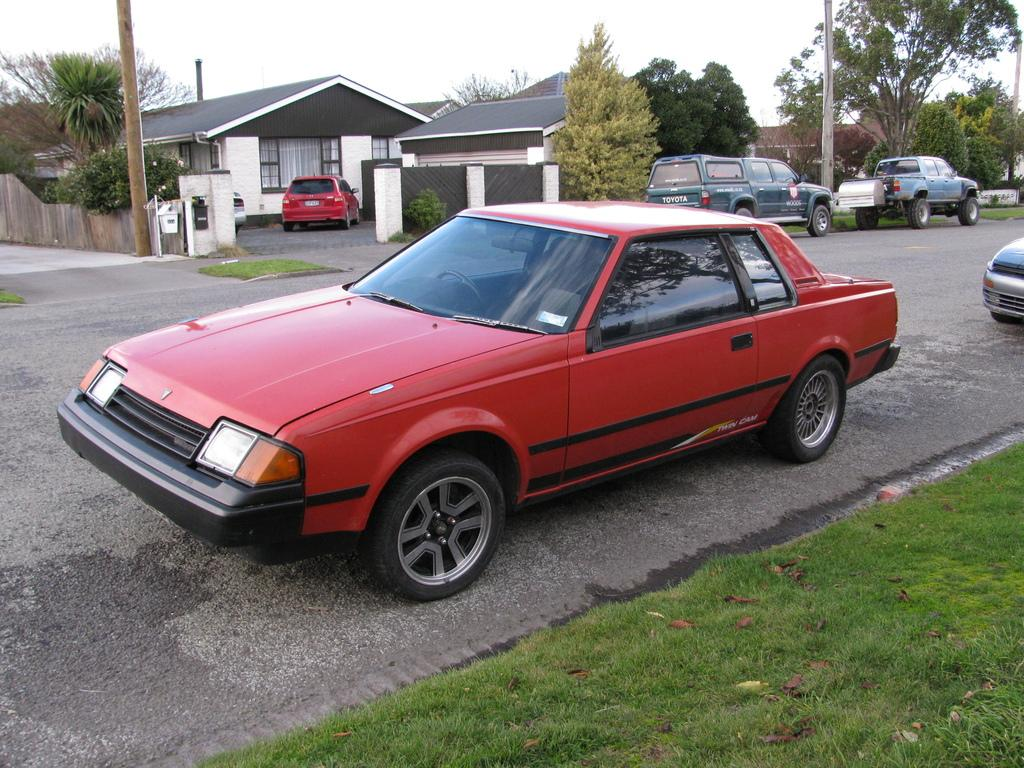What can be seen on the road in the image? There are vehicles on the road in the image. What is visible in the background of the image? There are houses, poles, a fence, trees, grass, plants, and the sky visible in the background of the image. Can you describe any other objects on the ground in the background of the image? There are other objects on the ground in the background of the image, but their specific nature is not mentioned in the facts. How many clocks are hanging on the trees in the image? There are no clocks mentioned in the image; it only describes vehicles on the road and various objects in the background. Is there a water fountain visible in the image? There is no mention of a water fountain in the image; it only describes vehicles on the road and various objects in the background. 